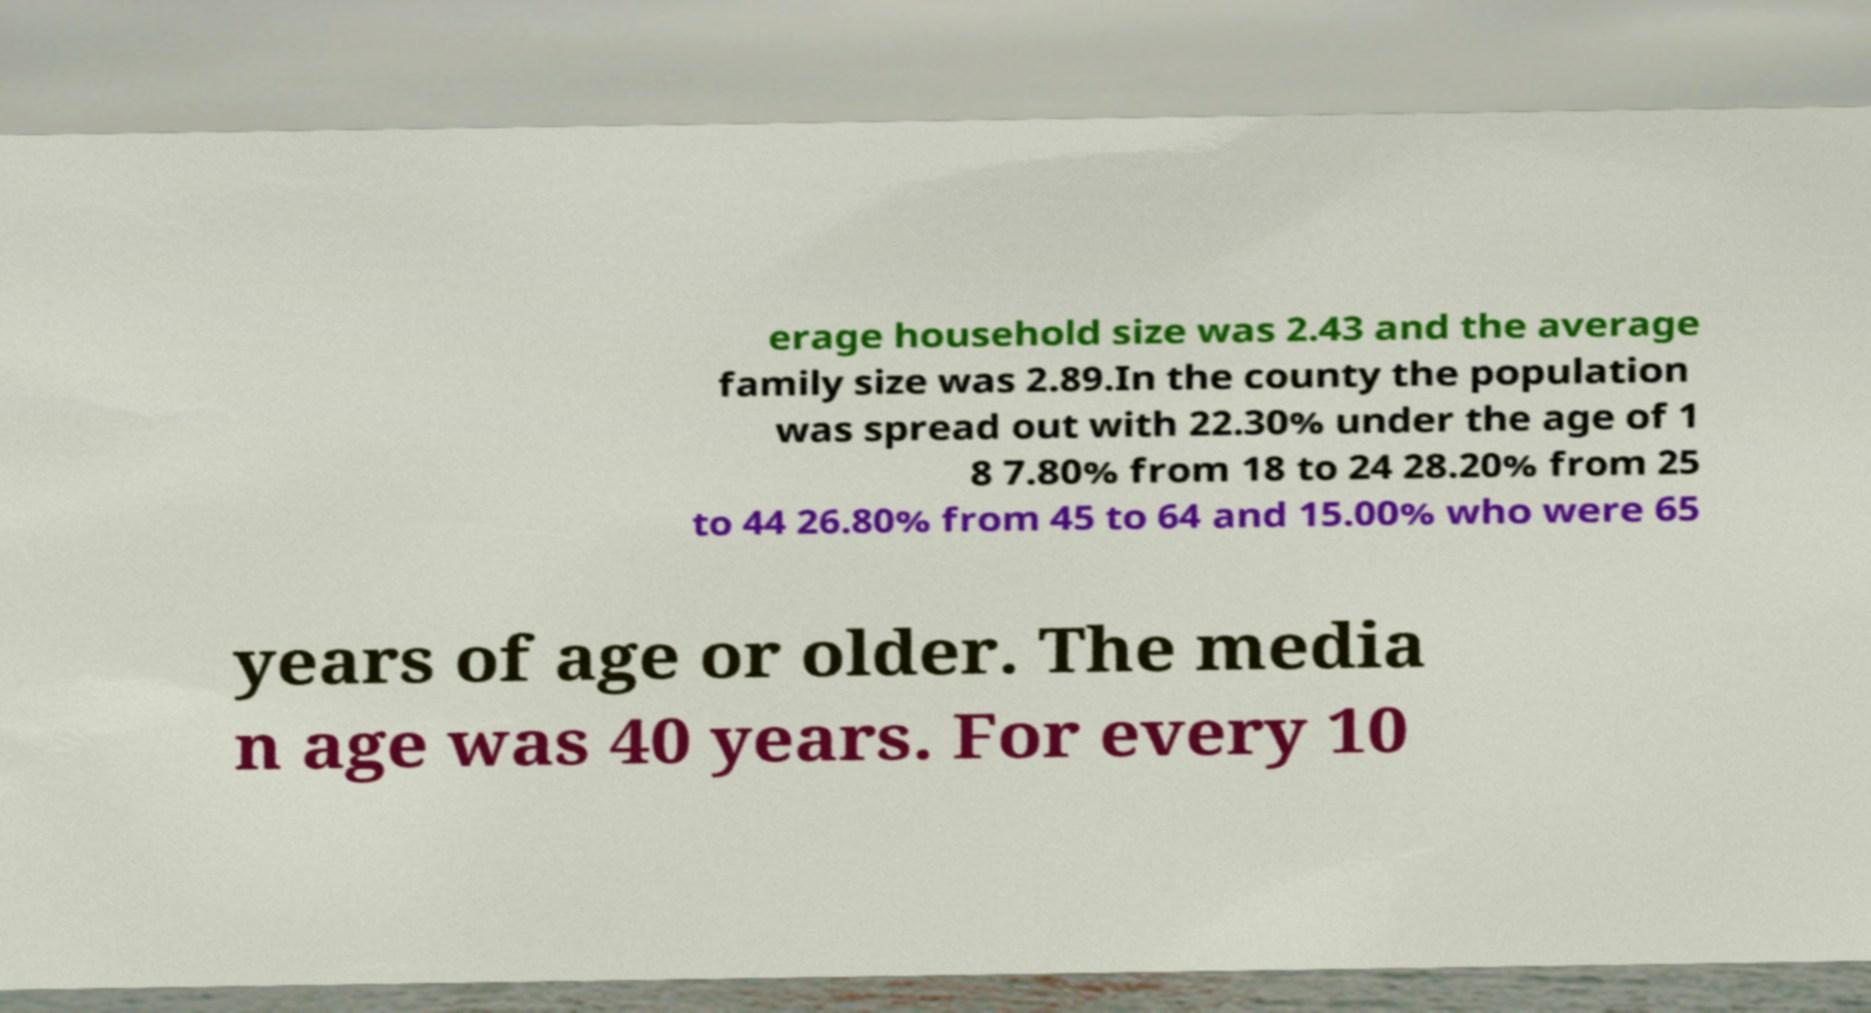Can you read and provide the text displayed in the image?This photo seems to have some interesting text. Can you extract and type it out for me? erage household size was 2.43 and the average family size was 2.89.In the county the population was spread out with 22.30% under the age of 1 8 7.80% from 18 to 24 28.20% from 25 to 44 26.80% from 45 to 64 and 15.00% who were 65 years of age or older. The media n age was 40 years. For every 10 